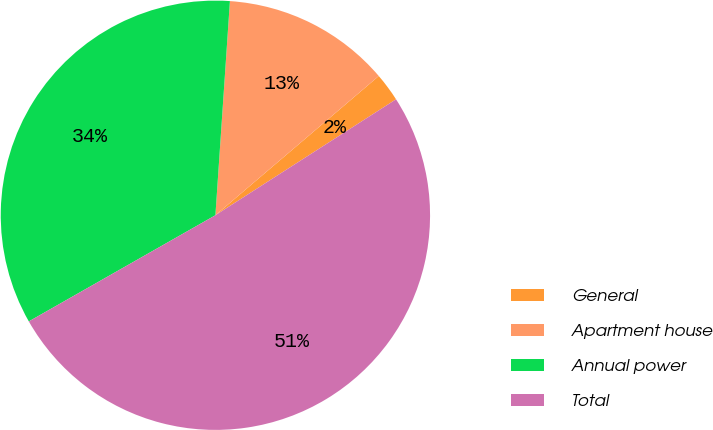Convert chart to OTSL. <chart><loc_0><loc_0><loc_500><loc_500><pie_chart><fcel>General<fcel>Apartment house<fcel>Annual power<fcel>Total<nl><fcel>2.15%<fcel>12.69%<fcel>34.31%<fcel>50.85%<nl></chart> 